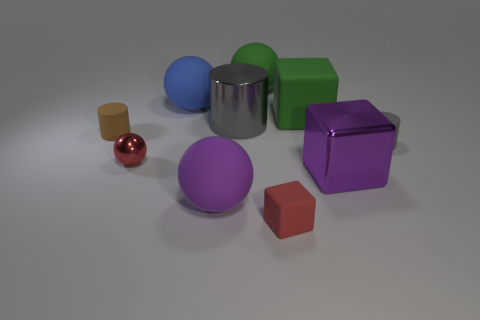What is the material of the blue object?
Ensure brevity in your answer.  Rubber. What is the shape of the large blue matte object that is behind the cylinder on the left side of the gray metallic cylinder?
Your response must be concise. Sphere. What number of other objects are there of the same shape as the purple rubber object?
Provide a succinct answer. 3. There is a large gray metal thing; are there any large cubes behind it?
Offer a very short reply. Yes. The metal sphere has what color?
Keep it short and to the point. Red. There is a tiny metallic object; is its color the same as the matte cube that is in front of the gray rubber cylinder?
Offer a terse response. Yes. Are there any gray rubber cylinders of the same size as the purple cube?
Keep it short and to the point. No. The rubber cube that is the same color as the small shiny object is what size?
Provide a short and direct response. Small. There is a ball behind the large blue ball; what is it made of?
Offer a very short reply. Rubber. Are there the same number of big purple blocks on the left side of the large purple ball and large green rubber balls that are in front of the blue rubber sphere?
Keep it short and to the point. Yes. 